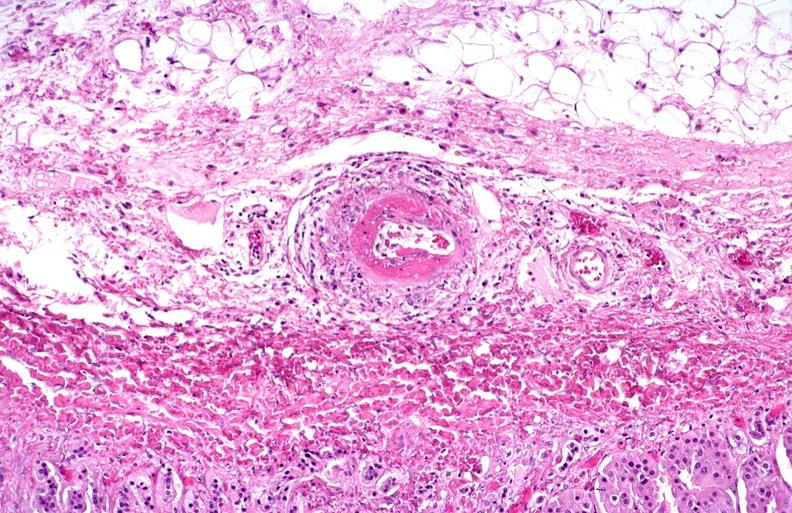where is this from?
Answer the question using a single word or phrase. Vasculature 